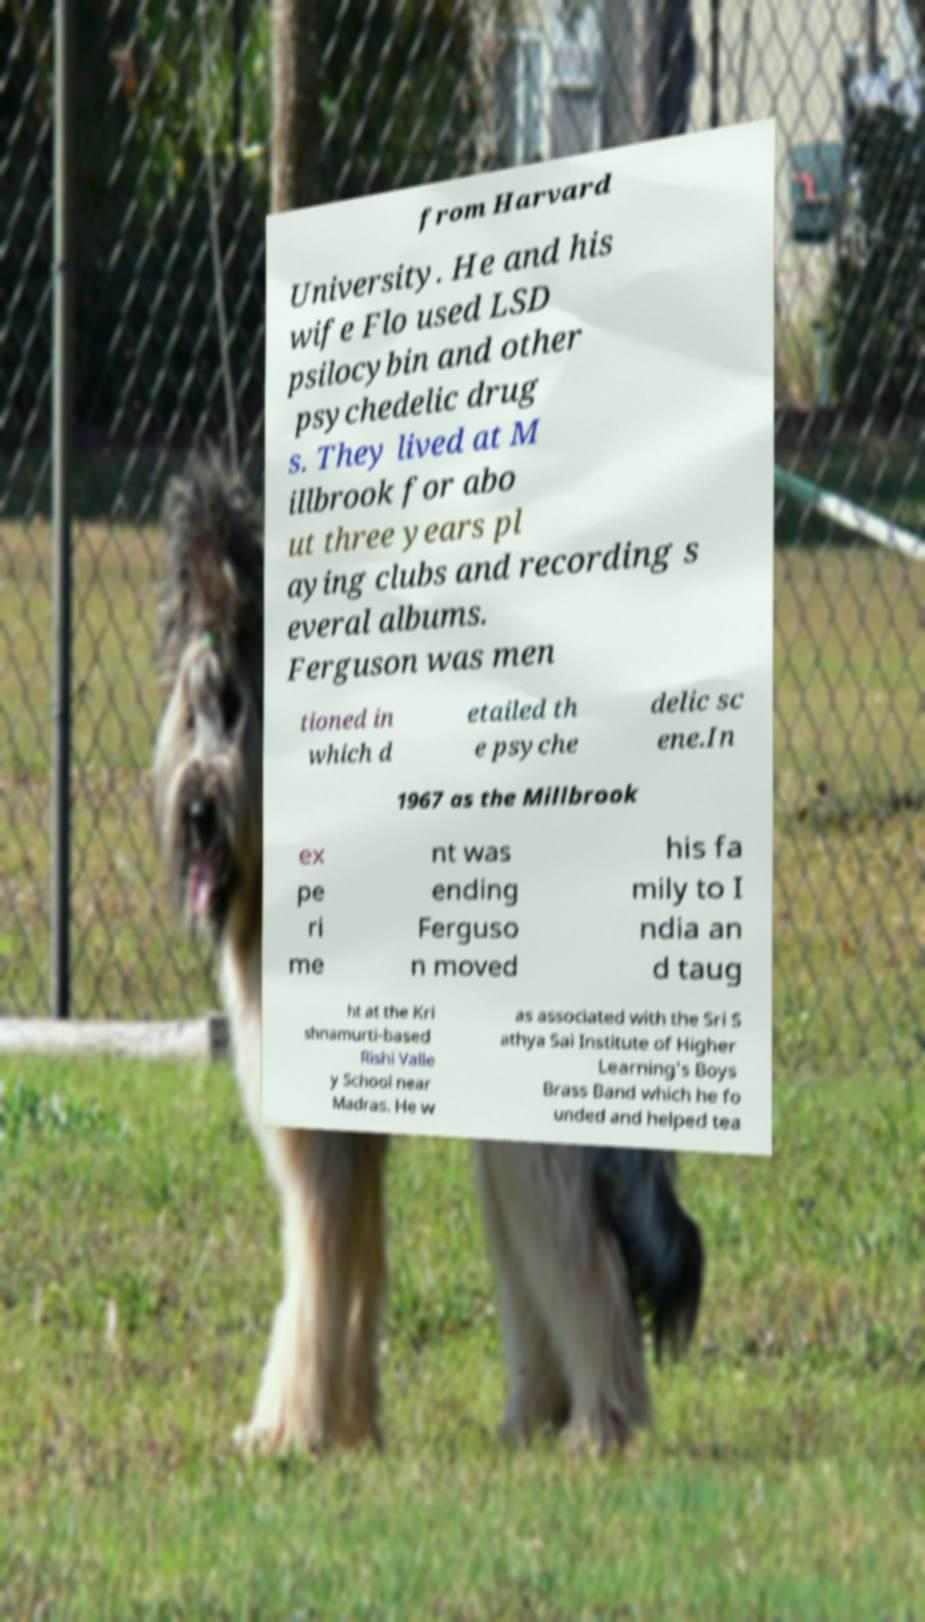I need the written content from this picture converted into text. Can you do that? from Harvard University. He and his wife Flo used LSD psilocybin and other psychedelic drug s. They lived at M illbrook for abo ut three years pl aying clubs and recording s everal albums. Ferguson was men tioned in which d etailed th e psyche delic sc ene.In 1967 as the Millbrook ex pe ri me nt was ending Ferguso n moved his fa mily to I ndia an d taug ht at the Kri shnamurti-based Rishi Valle y School near Madras. He w as associated with the Sri S athya Sai Institute of Higher Learning's Boys Brass Band which he fo unded and helped tea 